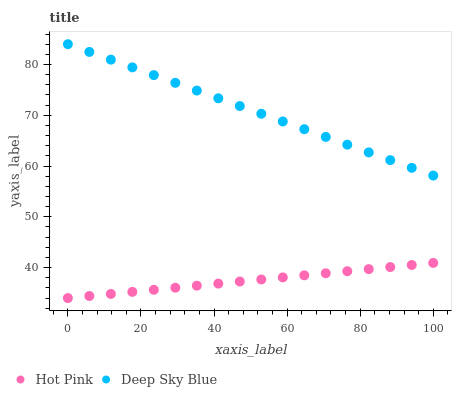Does Hot Pink have the minimum area under the curve?
Answer yes or no. Yes. Does Deep Sky Blue have the maximum area under the curve?
Answer yes or no. Yes. Does Deep Sky Blue have the minimum area under the curve?
Answer yes or no. No. Is Hot Pink the smoothest?
Answer yes or no. Yes. Is Deep Sky Blue the roughest?
Answer yes or no. Yes. Is Deep Sky Blue the smoothest?
Answer yes or no. No. Does Hot Pink have the lowest value?
Answer yes or no. Yes. Does Deep Sky Blue have the lowest value?
Answer yes or no. No. Does Deep Sky Blue have the highest value?
Answer yes or no. Yes. Is Hot Pink less than Deep Sky Blue?
Answer yes or no. Yes. Is Deep Sky Blue greater than Hot Pink?
Answer yes or no. Yes. Does Hot Pink intersect Deep Sky Blue?
Answer yes or no. No. 